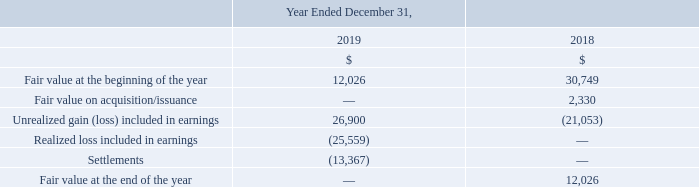Stock purchase warrants
Prior to the 2019 Brookfield Transaction, Teekay held 15.5 million common unit warrants (or the Brookfield Transaction Warrants) issued by Altera to Teekay in connection with the 2017 Brookfield Transaction (see Note 4) and 1,755,000 warrants to purchase common units of Altera issued to Teekay in connection with Altera's private placement of Series D Preferred Units in June 2016 (or the Series D Warrants). In May 2019, Teekay sold to Brookfield all of the Company’s remaining interests in Altera, which included, among other things, both the Brookfield Transaction Warrants and Series D Warrants.
Changes in fair value during the years ended December 31, 2019 and 2018 for the Company’s Brookfield Transaction Warrants and the Series D Warrants, which were measured at fair value using significant unobservable inputs (Level 3), are as follows:
Prior to 2019, what was the amount of warrants held by Brookfield Transaction, Teekay? 15.5 million. When did Teekay sell to Brookfield all of the Company’s remaining interests in Altera? May 2019. What was the Fair value at the beginning of the year for 2019 and 2018? 12,026, 30,749. In which year was Fair value at the beginning of the year less than 15,000 thousands? Locate and analyze fair value at the beginning of the year in row 4
answer: 2019. What is the average Fair value on acquisition/issuance?
Answer scale should be: thousand. (0 + 2,330) / 2
Answer: 1165. What is the increase / (decrease) in the Fair value at the end of the year from 2018 to 2019?
Answer scale should be: thousand. 0 - 12,026
Answer: -12026. 